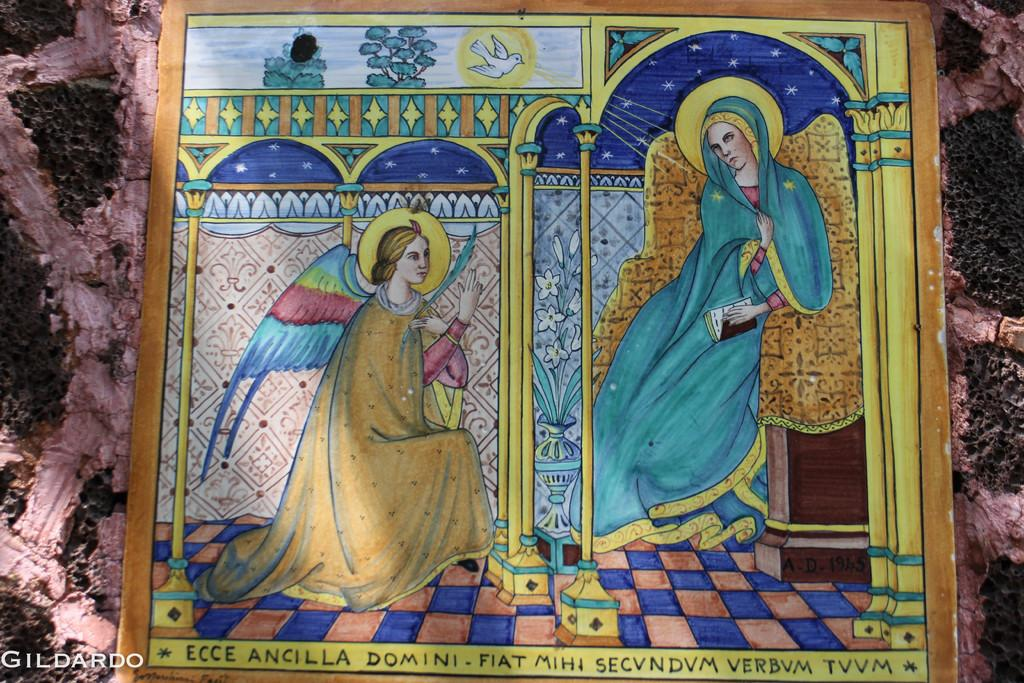What is the main object in the image? There is a frame in the image. What can be seen inside the frame? The frame contains pictures of two women. Where is the frame located? The frame is on a wall. What type of insurance policy is mentioned in the pictures of the two women? There is no mention of any insurance policy in the pictures of the two women; they are simply depicted in the frame. 